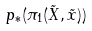Convert formula to latex. <formula><loc_0><loc_0><loc_500><loc_500>p _ { * } ( \pi _ { 1 } ( \tilde { X } , \tilde { x } ) )</formula> 